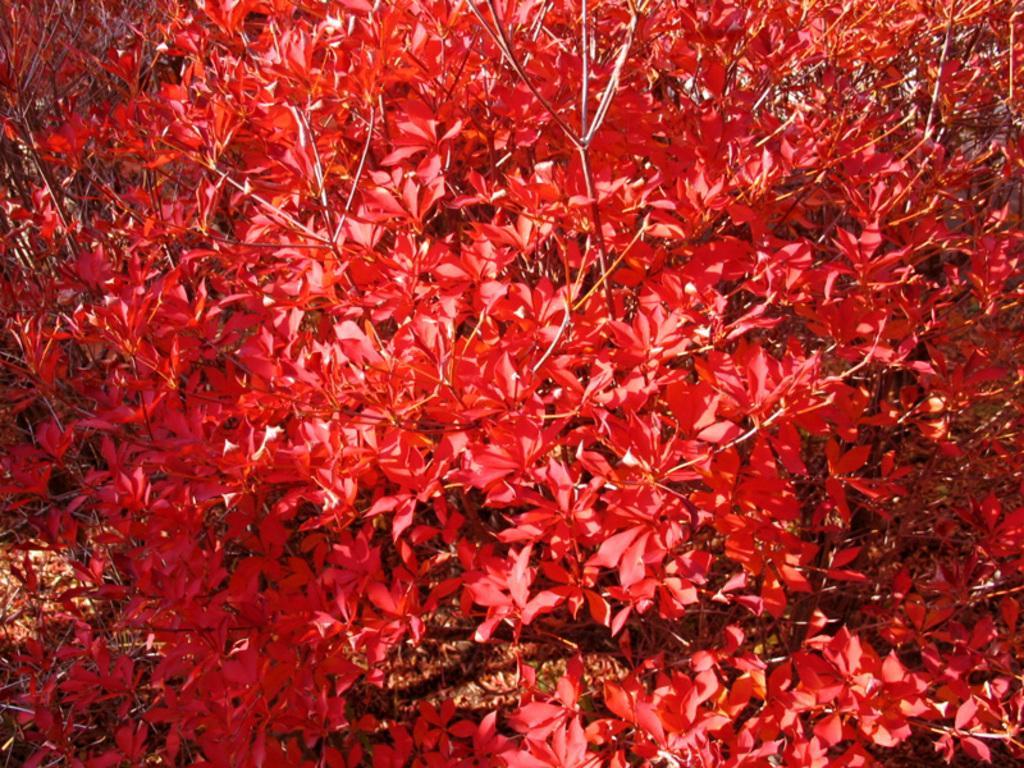Describe this image in one or two sentences. In this image we can see atoms with red leaves. 